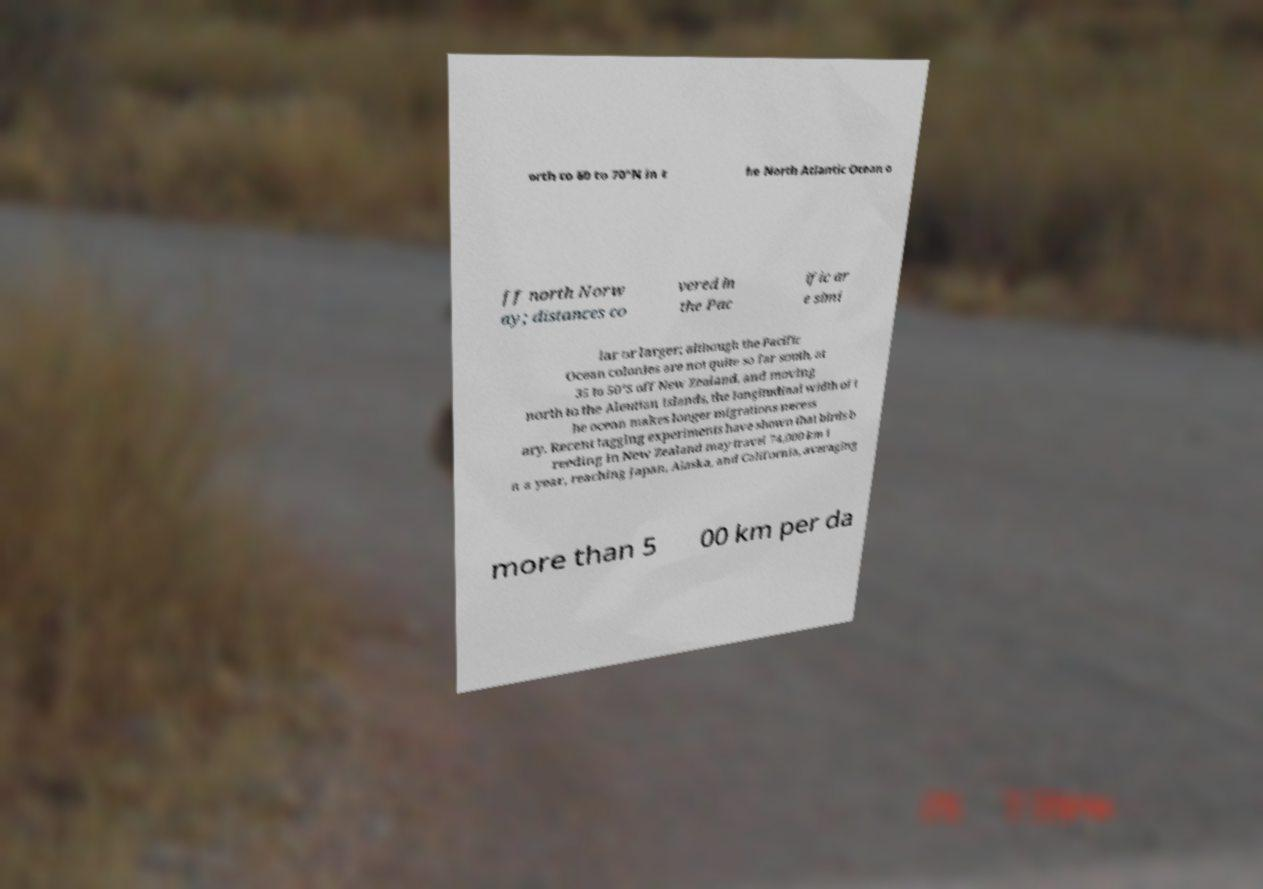Please read and relay the text visible in this image. What does it say? orth to 60 to 70°N in t he North Atlantic Ocean o ff north Norw ay; distances co vered in the Pac ific ar e simi lar or larger; although the Pacific Ocean colonies are not quite so far south, at 35 to 50°S off New Zealand, and moving north to the Aleutian Islands, the longitudinal width of t he ocean makes longer migrations necess ary. Recent tagging experiments have shown that birds b reeding in New Zealand may travel 74,000 km i n a year, reaching Japan, Alaska, and California, averaging more than 5 00 km per da 